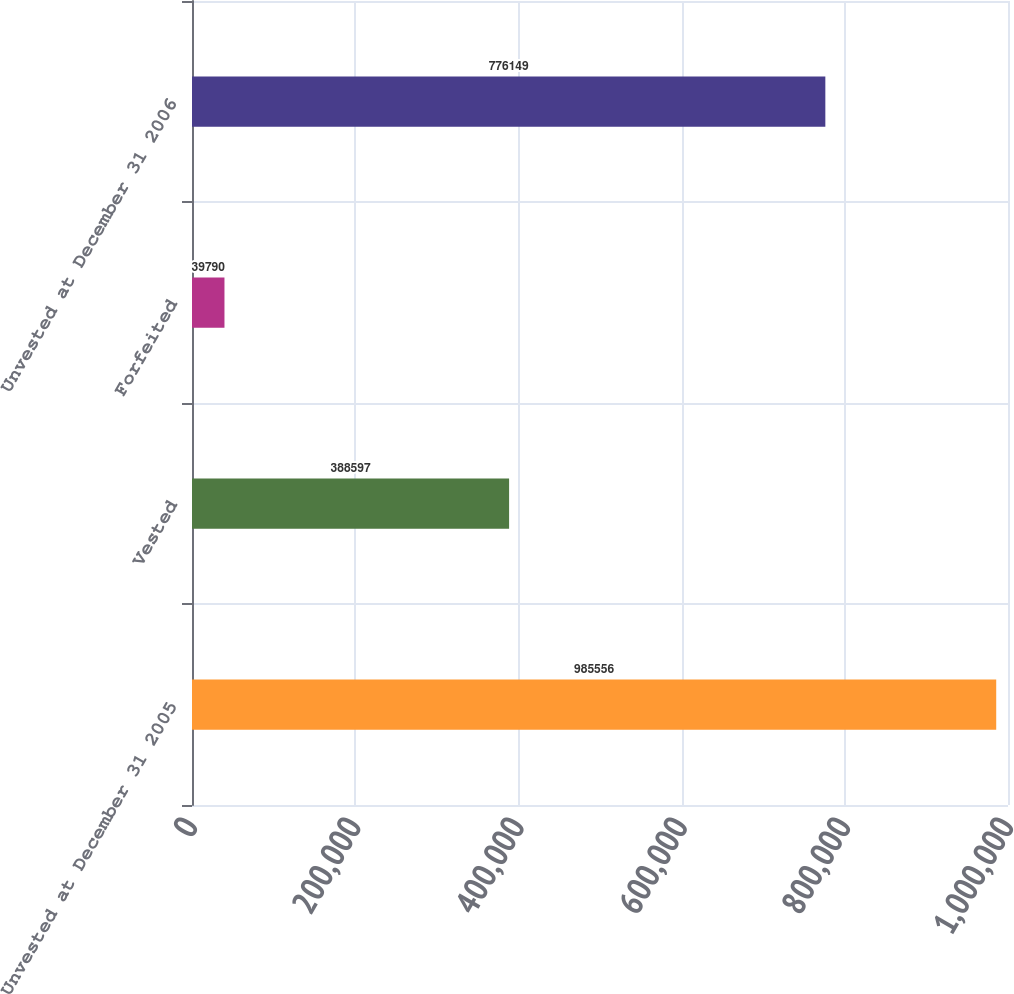Convert chart. <chart><loc_0><loc_0><loc_500><loc_500><bar_chart><fcel>Unvested at December 31 2005<fcel>Vested<fcel>Forfeited<fcel>Unvested at December 31 2006<nl><fcel>985556<fcel>388597<fcel>39790<fcel>776149<nl></chart> 